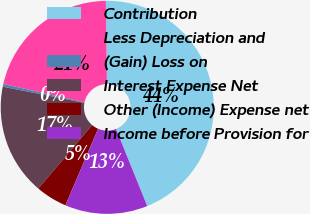Convert chart. <chart><loc_0><loc_0><loc_500><loc_500><pie_chart><fcel>Contribution<fcel>Less Depreciation and<fcel>(Gain) Loss on<fcel>Interest Expense Net<fcel>Other (Income) Expense net<fcel>Income before Provision for<nl><fcel>44.09%<fcel>21.27%<fcel>0.42%<fcel>16.9%<fcel>4.78%<fcel>12.54%<nl></chart> 